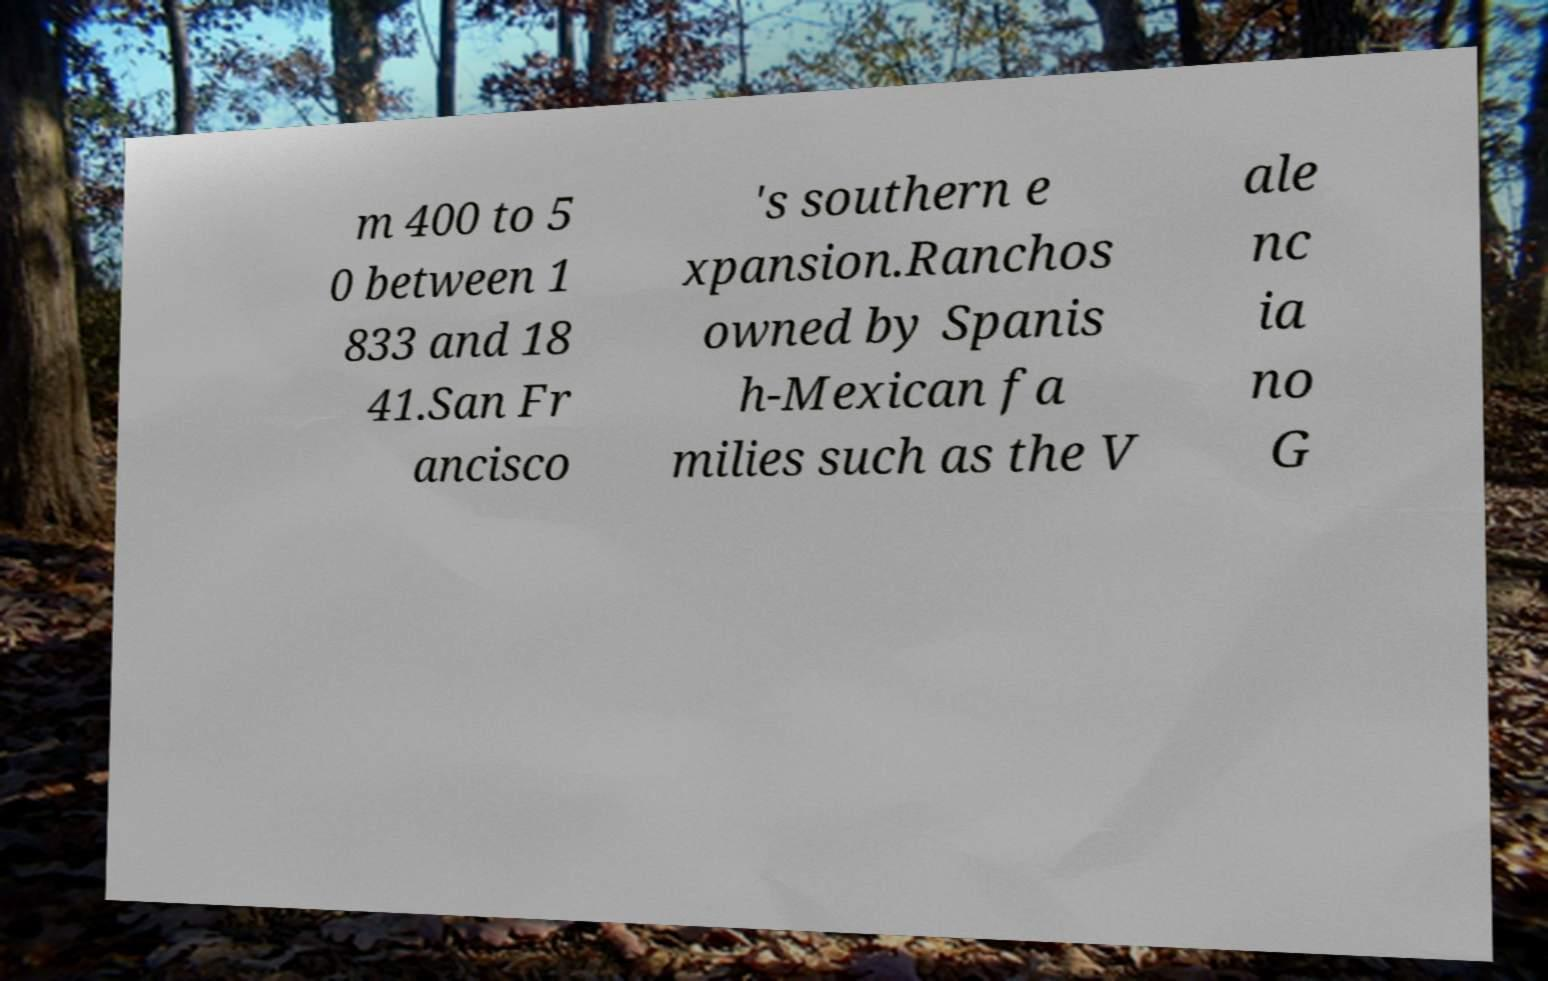What messages or text are displayed in this image? I need them in a readable, typed format. m 400 to 5 0 between 1 833 and 18 41.San Fr ancisco 's southern e xpansion.Ranchos owned by Spanis h-Mexican fa milies such as the V ale nc ia no G 